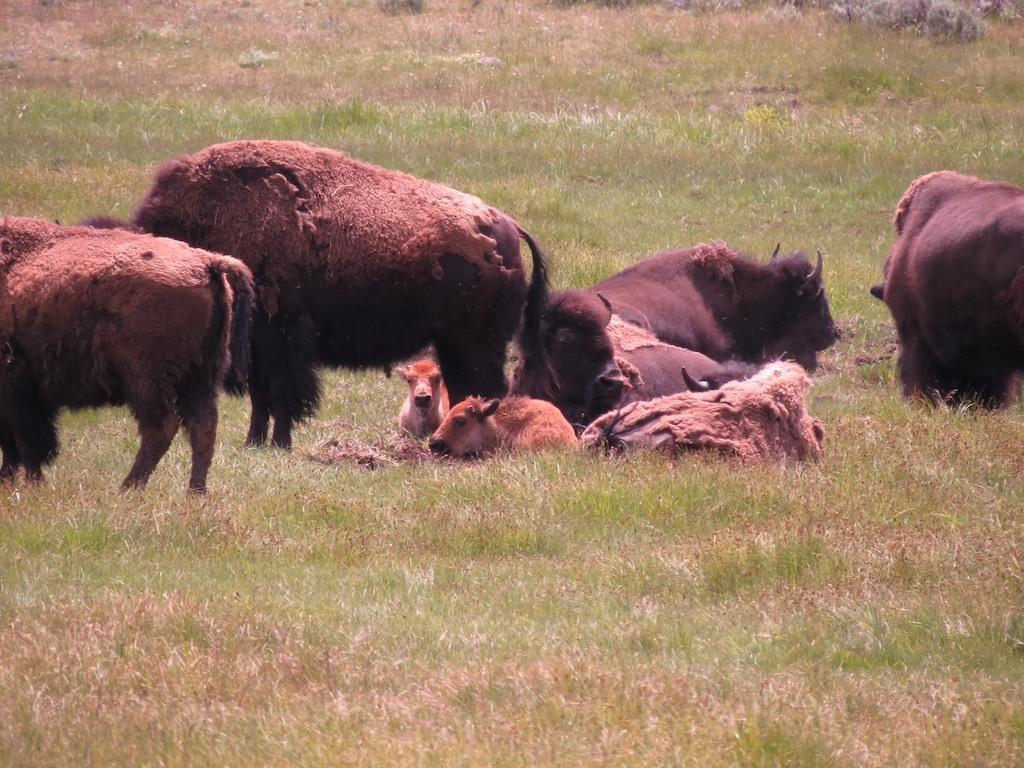Describe this image in one or two sentences. In the foreground of this image, there are animals on the grass. 